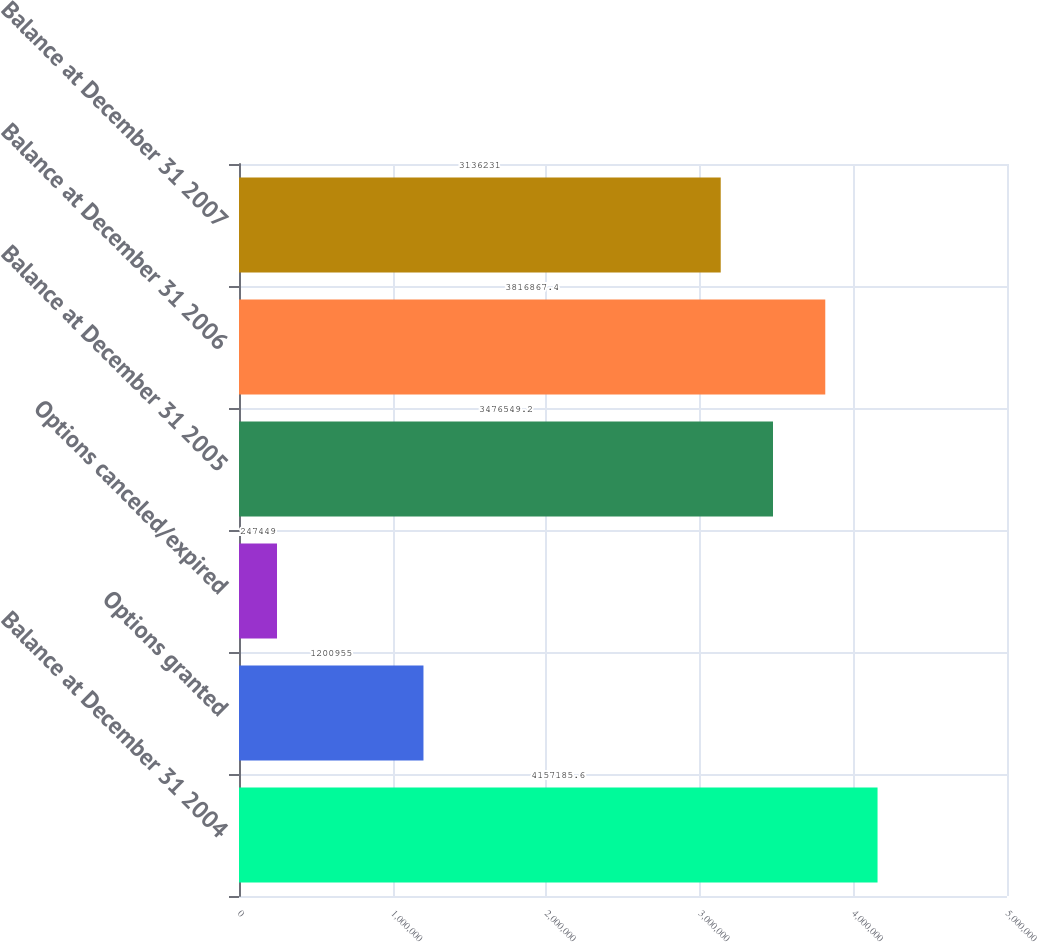Convert chart. <chart><loc_0><loc_0><loc_500><loc_500><bar_chart><fcel>Balance at December 31 2004<fcel>Options granted<fcel>Options canceled/expired<fcel>Balance at December 31 2005<fcel>Balance at December 31 2006<fcel>Balance at December 31 2007<nl><fcel>4.15719e+06<fcel>1.20096e+06<fcel>247449<fcel>3.47655e+06<fcel>3.81687e+06<fcel>3.13623e+06<nl></chart> 